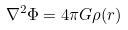Convert formula to latex. <formula><loc_0><loc_0><loc_500><loc_500>\nabla ^ { 2 } \Phi = 4 \pi G \rho ( r )</formula> 